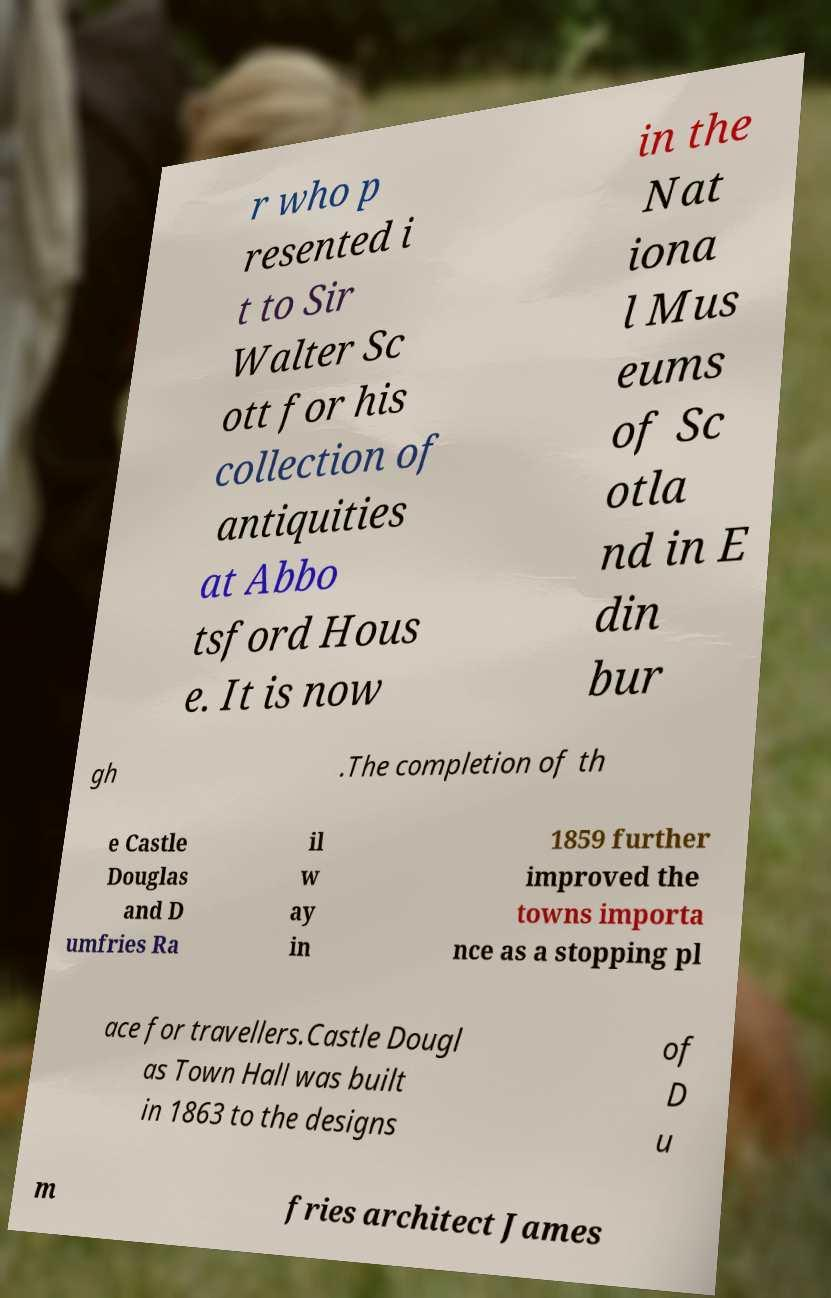For documentation purposes, I need the text within this image transcribed. Could you provide that? r who p resented i t to Sir Walter Sc ott for his collection of antiquities at Abbo tsford Hous e. It is now in the Nat iona l Mus eums of Sc otla nd in E din bur gh .The completion of th e Castle Douglas and D umfries Ra il w ay in 1859 further improved the towns importa nce as a stopping pl ace for travellers.Castle Dougl as Town Hall was built in 1863 to the designs of D u m fries architect James 